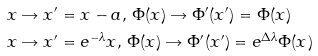<formula> <loc_0><loc_0><loc_500><loc_500>& x \rightarrow x ^ { \prime } = x - a , \, \Phi ( x ) \rightarrow \Phi ^ { \prime } ( x ^ { \prime } ) = \Phi ( x ) \\ & x \rightarrow x ^ { \prime } = e ^ { - \lambda } x , \, \Phi ( x ) \rightarrow \Phi ^ { \prime } ( x ^ { \prime } ) = e ^ { \Delta \lambda } \Phi ( x )</formula> 